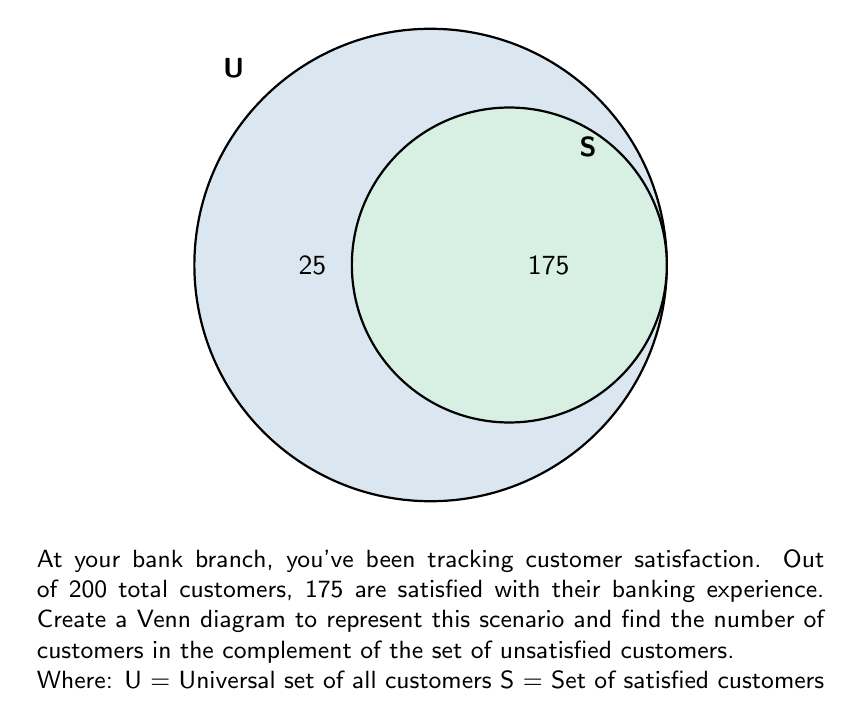Can you answer this question? Let's approach this step-by-step:

1) First, let's identify our sets:
   - U = Universal set of all customers = 200
   - S = Set of satisfied customers = 175

2) The set of unsatisfied customers, let's call it U', can be found by:
   $U' = U - S = 200 - 175 = 25$

3) Now, we need to find the complement of U'. In set theory, the complement of a set A is denoted as A^c and includes all elements in the universal set that are not in A.

4) In this case, the complement of U' would be all customers who are not unsatisfied, which is the same as the set of satisfied customers S.

5) Therefore, $(U')^c = S = 175$

This can be verified by the set theory principle:
$A^c = U - A$

In our case:
$(U')^c = U - U' = 200 - 25 = 175$

Thus, the complement of the set of unsatisfied customers contains 175 customers.
Answer: 175 